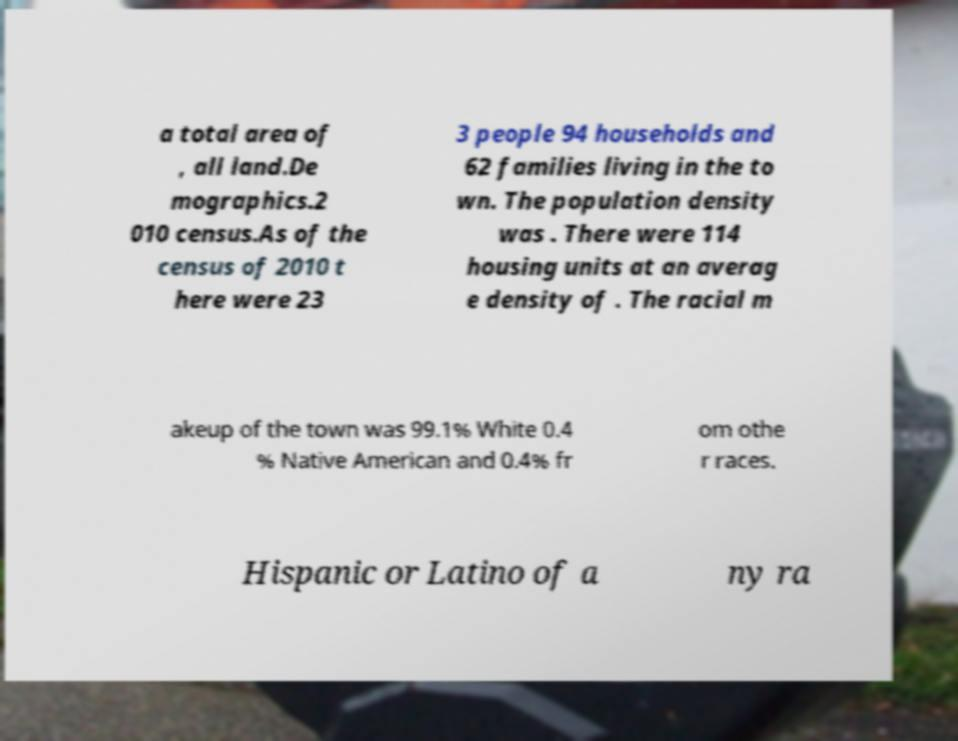There's text embedded in this image that I need extracted. Can you transcribe it verbatim? a total area of , all land.De mographics.2 010 census.As of the census of 2010 t here were 23 3 people 94 households and 62 families living in the to wn. The population density was . There were 114 housing units at an averag e density of . The racial m akeup of the town was 99.1% White 0.4 % Native American and 0.4% fr om othe r races. Hispanic or Latino of a ny ra 